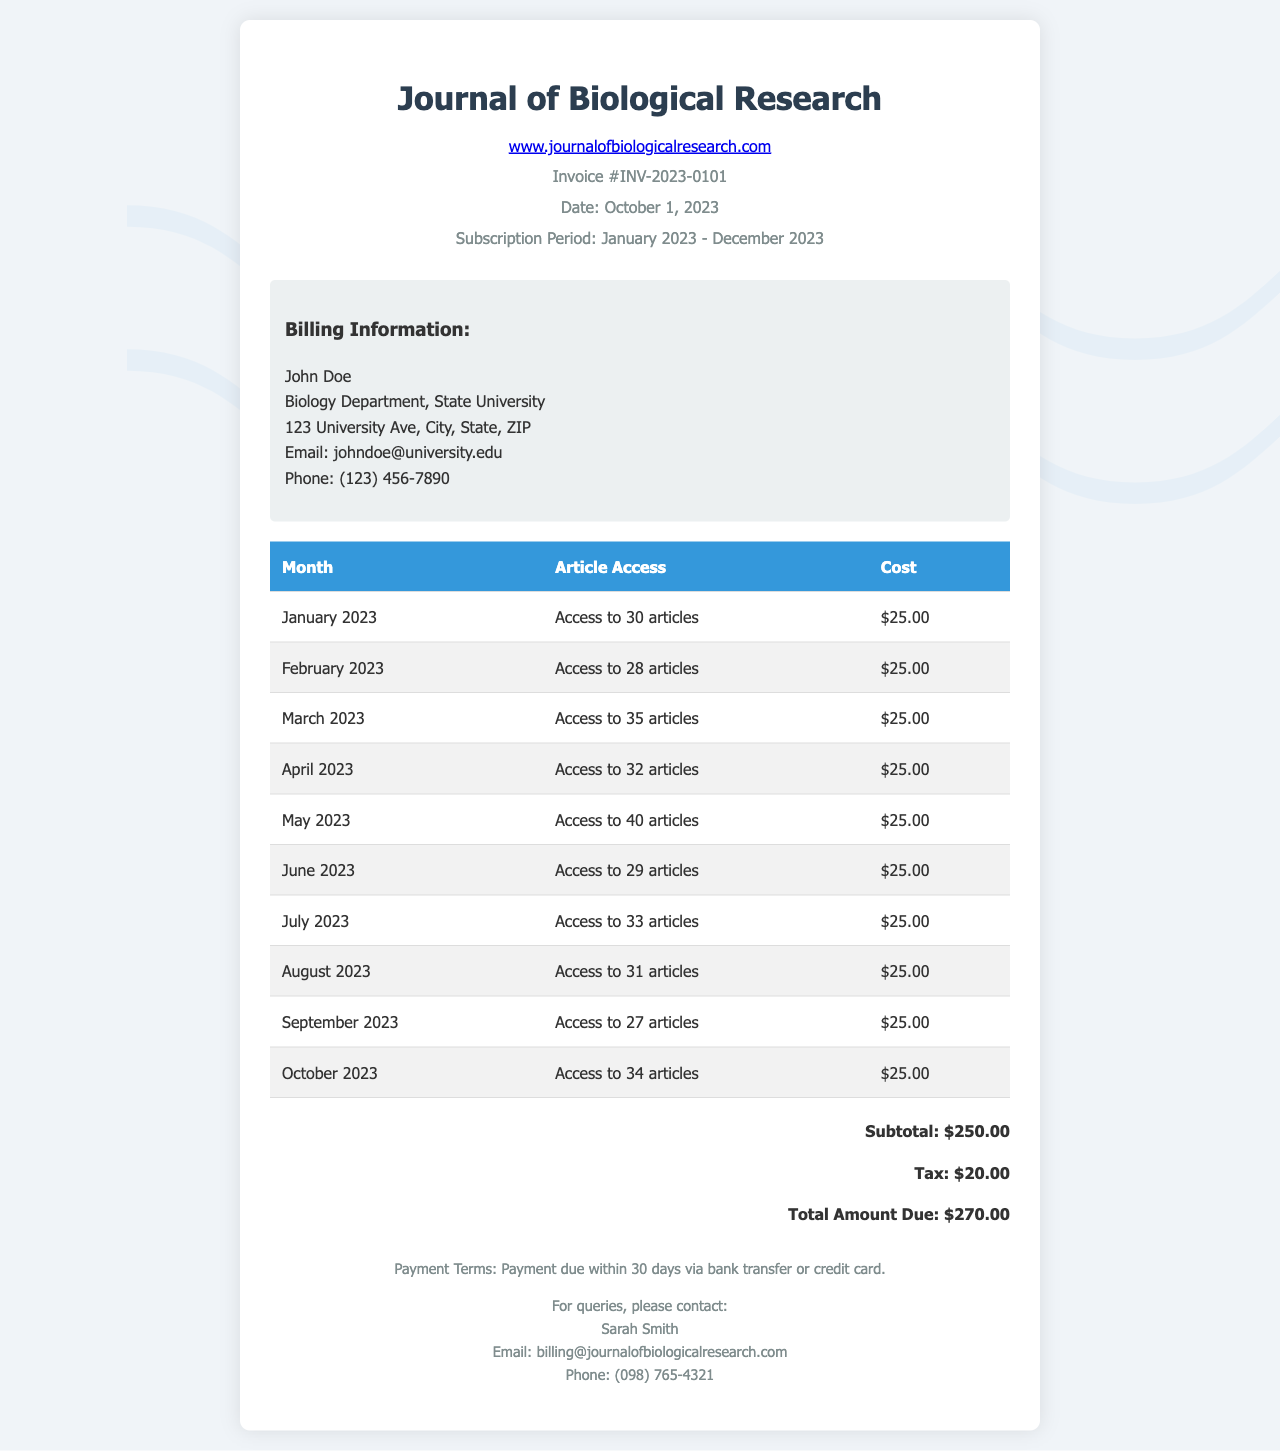What is the invoice number? The invoice number is stated clearly in the document.
Answer: INV-2023-0101 What is the total amount due? The total amount due is provided in the summary section at the end of the document.
Answer: $270.00 How many articles were accessed in May 2023? The number of articles accessed can be found in the itemized table for May 2023.
Answer: 40 articles What is the billing email address? The billing email address is provided in the footer of the document.
Answer: billing@journalofbiologicalresearch.com What is the subscription period? The subscription period is stated in the header section of the invoice.
Answer: January 2023 - December 2023 What is the subtotal before tax? The subtotal is clearly indicated in the price summary section.
Answer: $250.00 How many articles were accessed in September 2023? The month of September 2023 is listed in the invoice with the corresponding number of accessible articles.
Answer: 27 articles What are the payment terms? The payment terms are described at the bottom of the invoice in the footer.
Answer: Payment due within 30 days What is the tax amount? The tax amount is specified in the summary section of the invoice.
Answer: $20.00 Who should be contacted for billing queries? The contact for billing queries is mentioned in the footer, specifying the individual's name and details.
Answer: Sarah Smith 